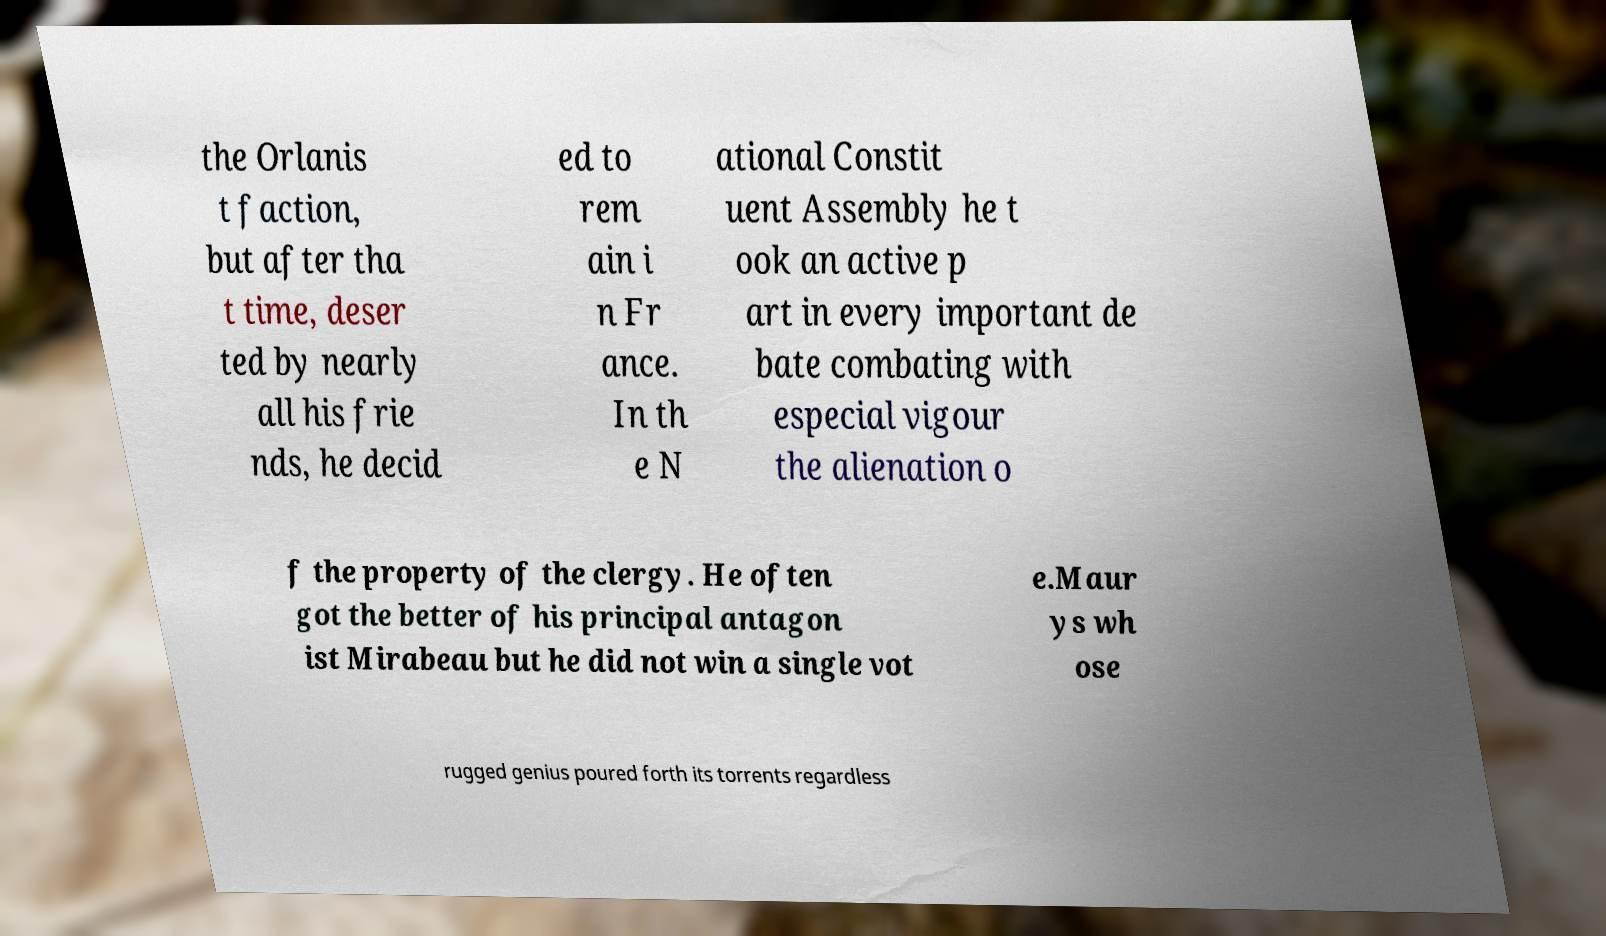Can you read and provide the text displayed in the image?This photo seems to have some interesting text. Can you extract and type it out for me? the Orlanis t faction, but after tha t time, deser ted by nearly all his frie nds, he decid ed to rem ain i n Fr ance. In th e N ational Constit uent Assembly he t ook an active p art in every important de bate combating with especial vigour the alienation o f the property of the clergy. He often got the better of his principal antagon ist Mirabeau but he did not win a single vot e.Maur ys wh ose rugged genius poured forth its torrents regardless 